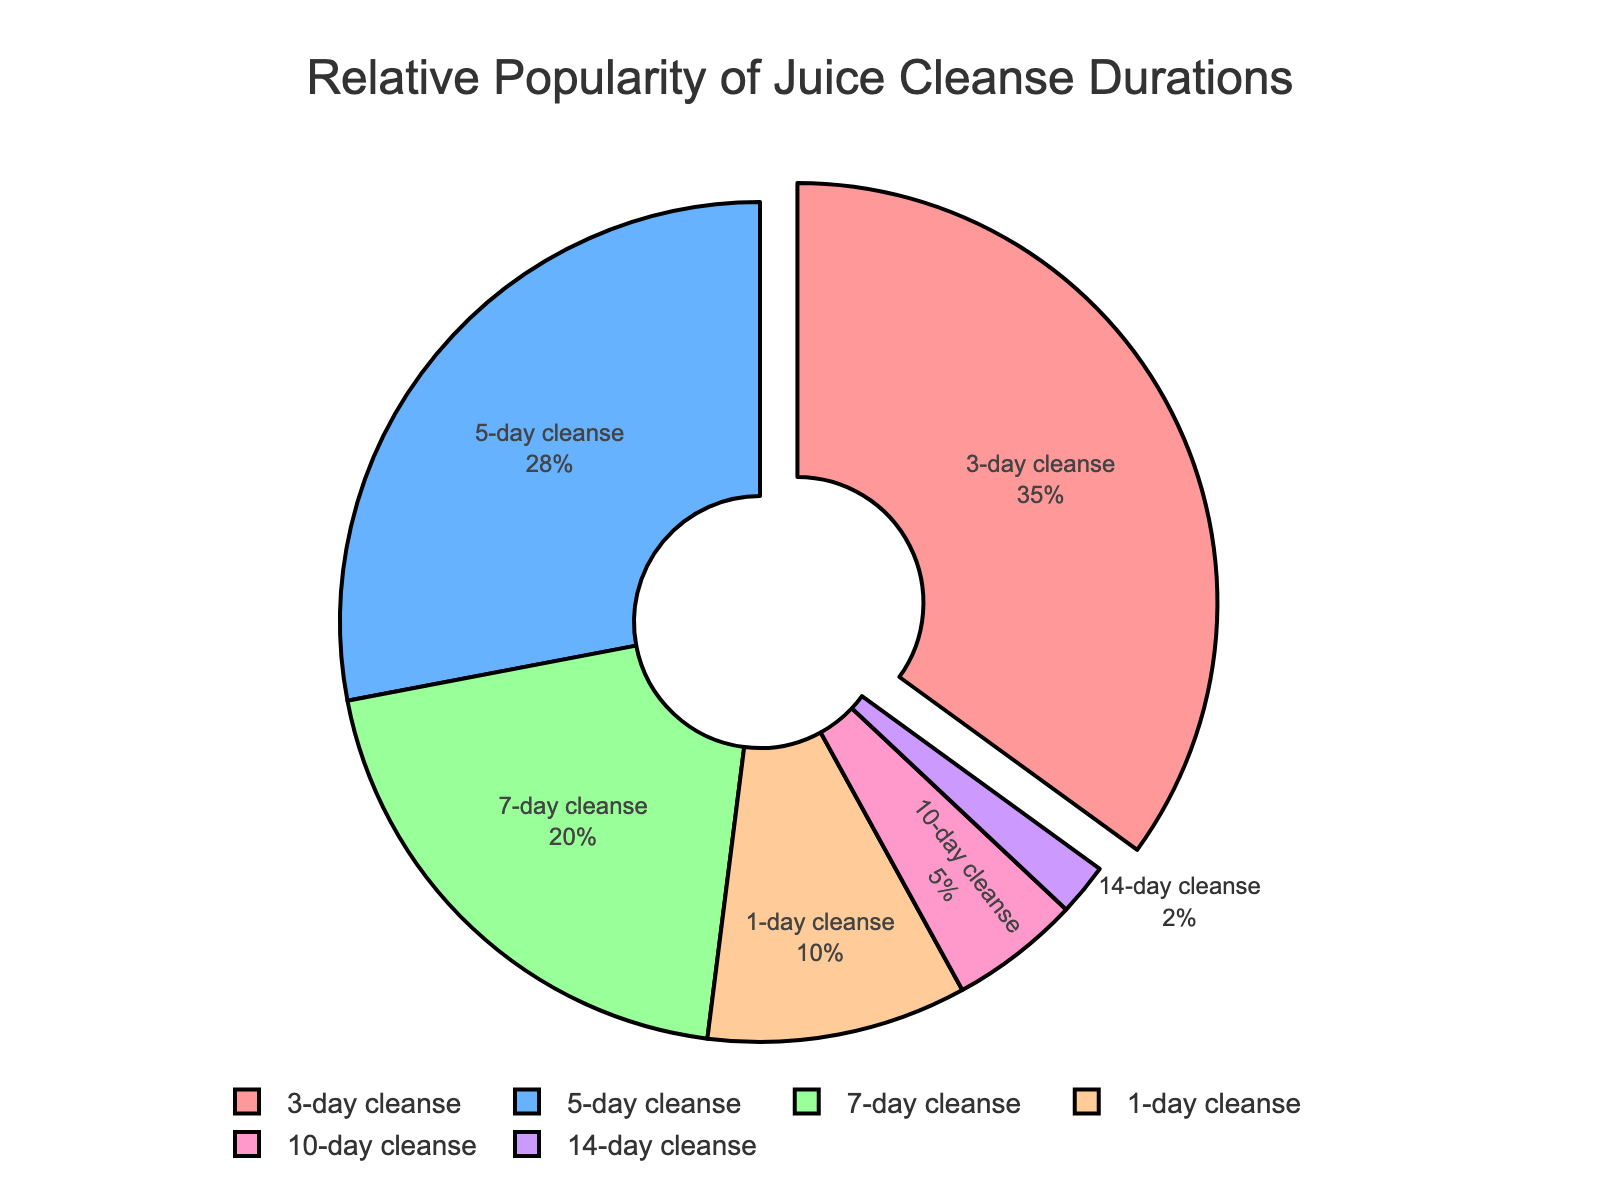What percentage of people prefer a 3-day cleanse? The figure shows the relative popularity of different juice cleanse durations. The 3-day cleanse slice is highlighted and shows 35%.
Answer: 35% Which is more popular, the 7-day cleanse or the 1-day cleanse, and by how much? The 7-day cleanse has a slice representing 20%, while the 1-day cleanse has a slice representing 10%. Subtracting 10% from 20% gives us the difference of 10%.
Answer: 7-day by 10% If you combine the popularity of the 10-day and 14-day cleanses, what percentage do you get? According to the figure, the 10-day cleanse is 5% and the 14-day cleanse is 2%. Adding these percentages together gives 7%.
Answer: 7% What is the proportion of people who prefer cleanses shorter than 5 days? The figure shows that 3-day cleanses account for 35%, and 1-day cleanses account for 10%. Adding 35% and 10% results in 45%.
Answer: 45% What is the most popular juice cleanse duration? The highlighted slice for the 3-day cleanse has the highest percentage, which is 35%, indicating it is the most popular.
Answer: 3-day Compare the popularity of the 5-day cleanse to the 14-day cleanse. The 5-day cleanse is represented by 28%, and the 14-day cleanse is represented by 2%. The 5-day cleanse is therefore much more popular.
Answer: 5-day is more popular How much more popular is a 5-day cleanse compared to a 10-day cleanse? The figure shows the 5-day cleanse at 28% and the 10-day cleanse at 5%. The difference between them is 28% - 5% = 23%.
Answer: 23% What percentage of people prefer cleanses that last a week or longer? Looking at the figure, the 7-day cleanse is 20%, the 10-day cleanse is 5%, and the 14-day cleanse is 2%. Adding these together gives 20% + 5% + 2% = 27%.
Answer: 27% Among the durations provided, which one is the least popular and what is its proportion? The 14-day cleanse slice is the smallest with a percentage of 2%, indicating it is the least popular.
Answer: 14-day, 2% If you had to recommend a cleanse duration based on popularity, which would you choose and why? The figure indicates that the 3-day cleanse is the most popular, with a percentage of 35%. This suggests it is the most preferred choice among fitness enthusiasts.
Answer: 3-day cleanse 